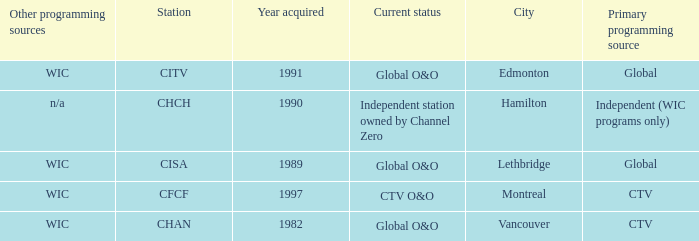Would you be able to parse every entry in this table? {'header': ['Other programming sources', 'Station', 'Year acquired', 'Current status', 'City', 'Primary programming source'], 'rows': [['WIC', 'CITV', '1991', 'Global O&O', 'Edmonton', 'Global'], ['n/a', 'CHCH', '1990', 'Independent station owned by Channel Zero', 'Hamilton', 'Independent (WIC programs only)'], ['WIC', 'CISA', '1989', 'Global O&O', 'Lethbridge', 'Global'], ['WIC', 'CFCF', '1997', 'CTV O&O', 'Montreal', 'CTV'], ['WIC', 'CHAN', '1982', 'Global O&O', 'Vancouver', 'CTV']]} What is the minimum number required for citv? 1991.0. 